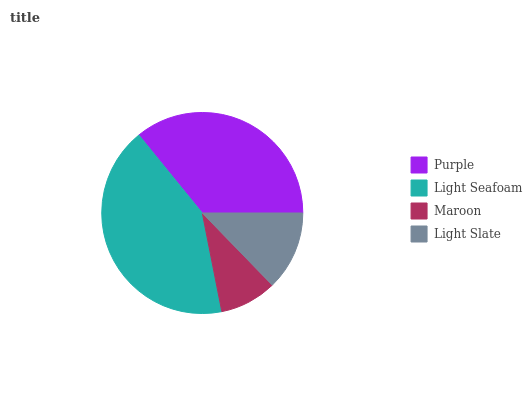Is Maroon the minimum?
Answer yes or no. Yes. Is Light Seafoam the maximum?
Answer yes or no. Yes. Is Light Seafoam the minimum?
Answer yes or no. No. Is Maroon the maximum?
Answer yes or no. No. Is Light Seafoam greater than Maroon?
Answer yes or no. Yes. Is Maroon less than Light Seafoam?
Answer yes or no. Yes. Is Maroon greater than Light Seafoam?
Answer yes or no. No. Is Light Seafoam less than Maroon?
Answer yes or no. No. Is Purple the high median?
Answer yes or no. Yes. Is Light Slate the low median?
Answer yes or no. Yes. Is Light Seafoam the high median?
Answer yes or no. No. Is Maroon the low median?
Answer yes or no. No. 